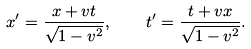Convert formula to latex. <formula><loc_0><loc_0><loc_500><loc_500>x ^ { \prime } = \frac { x + v t } { \sqrt { 1 - v ^ { 2 } } } , \quad t ^ { \prime } = \frac { t + v x } { \sqrt { 1 - v ^ { 2 } } } .</formula> 